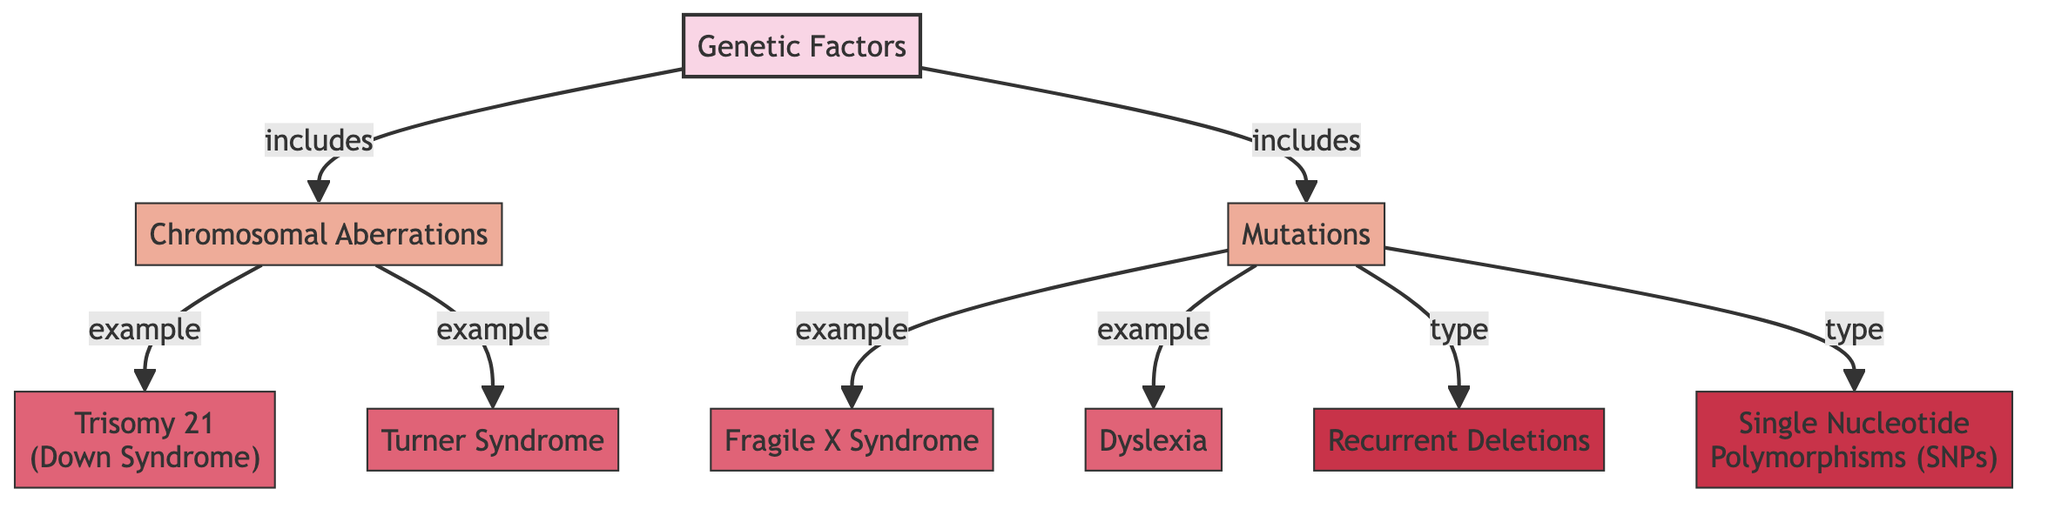What are the two main categories of genetic factors depicted in the diagram? The diagram shows two main categories connected to "Genetic Factors": "Chromosomal Aberrations" and "Mutations". These categories are directly linked to the main topic through arrows indicating inclusion.
Answer: Chromosomal Aberrations, Mutations How many example conditions are provided under chromosomal aberrations? The diagram lists two conditions under "Chromosomal Aberrations": "Trisomy 21 (Down Syndrome)" and "Turner Syndrome". By counting the examples connected to this node, we can see there are two.
Answer: 2 What type of mutations is associated with dyslexia in the diagram? Under the "Mutations" category, "Dyslexia" is shown as an example condition, while the diagram indicates types of mutations that include "Recurrent Deletions" and "Single Nucleotide Polymorphisms". Since dyslexia is categorized as an example rather than a specific type, it does not have a direct mutation type linked to it. Therefore, we refer back to the main category of mutations instead.
Answer: Mutations Which syndrome is associated with chromosomal aberration and demonstrates an example? Looking at the "Chromosomal Aberrations" section, "Trisomy 21 (Down Syndrome)" is explicitly listed as an example condition. This indicates it directly relates to the concept of chromosomal aberrations.
Answer: Trisomy 21 (Down Syndrome) What specific types of mutations are identified in the diagram? The diagram identifies two specific types of mutations associated with learning disabilities: "Recurrent Deletions" and "Single Nucleotide Polymorphisms". These are specifically categorized under the "Mutations" section of the diagram.
Answer: Recurrent Deletions, Single Nucleotide Polymorphisms 